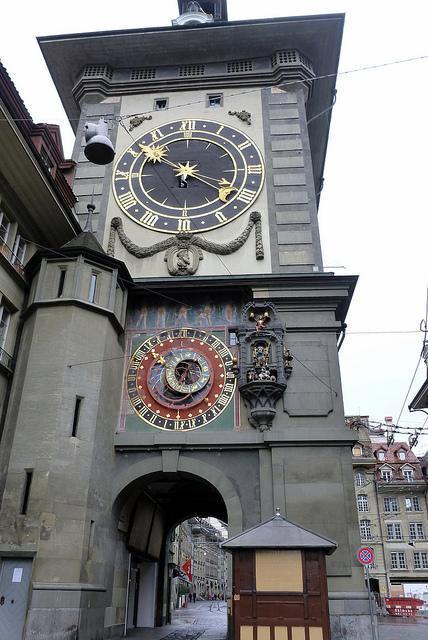How many clocks can you see?
Give a very brief answer. 2. 